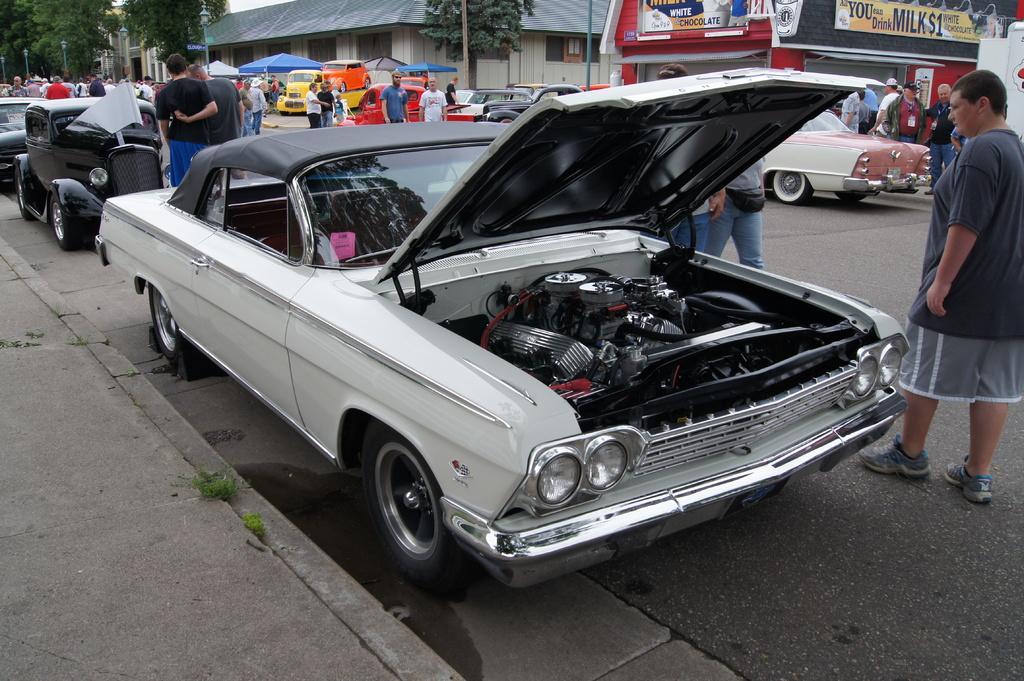Could you give a brief overview of what you see in this image? This image is taken indoors. At the bottom of the image there is a road and there is a sidewalk. In the background there are few trees and there are few houses. There are few poles. There are two boards with text on them. In the middle of the image many cars are parked on the road. Many people are standing on the road and a few are walking on the road. 